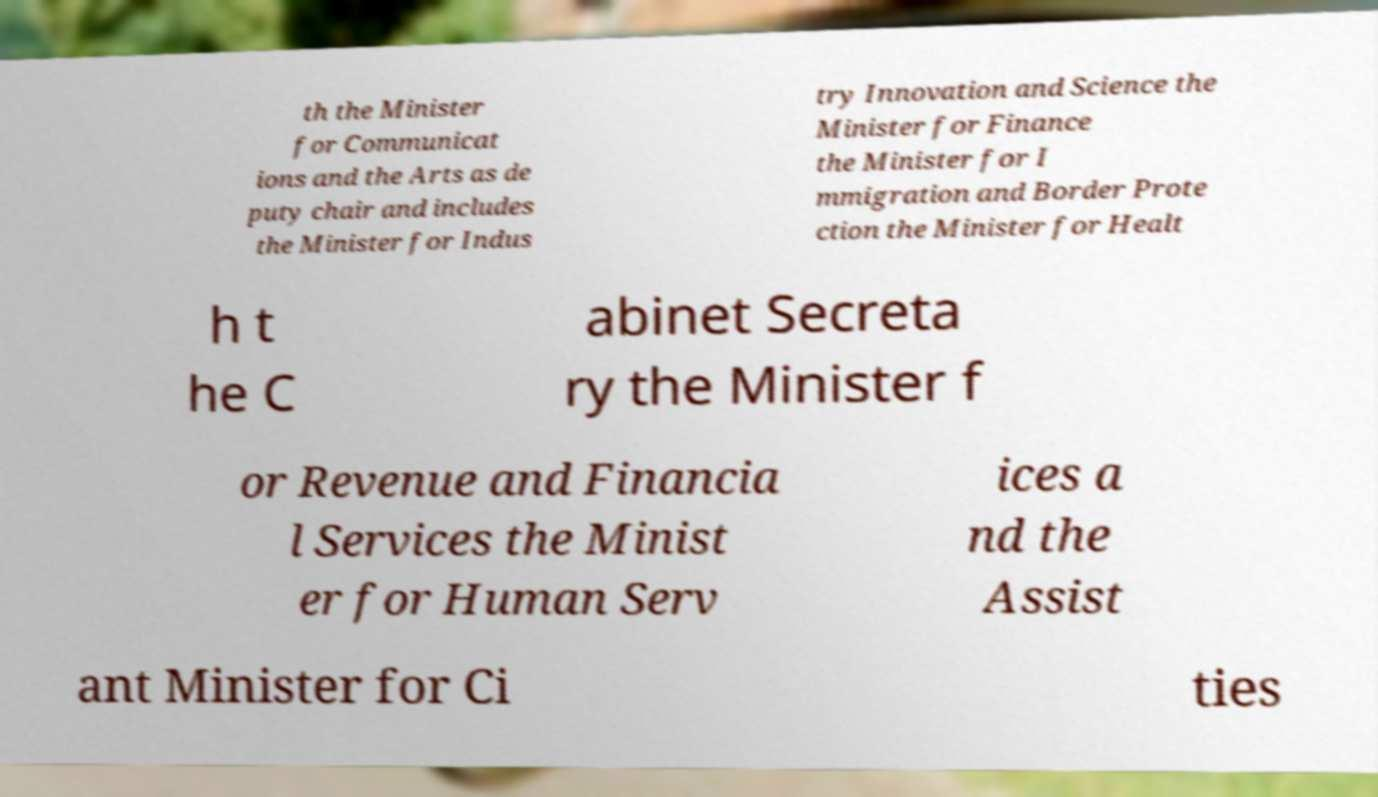Can you read and provide the text displayed in the image?This photo seems to have some interesting text. Can you extract and type it out for me? th the Minister for Communicat ions and the Arts as de puty chair and includes the Minister for Indus try Innovation and Science the Minister for Finance the Minister for I mmigration and Border Prote ction the Minister for Healt h t he C abinet Secreta ry the Minister f or Revenue and Financia l Services the Minist er for Human Serv ices a nd the Assist ant Minister for Ci ties 